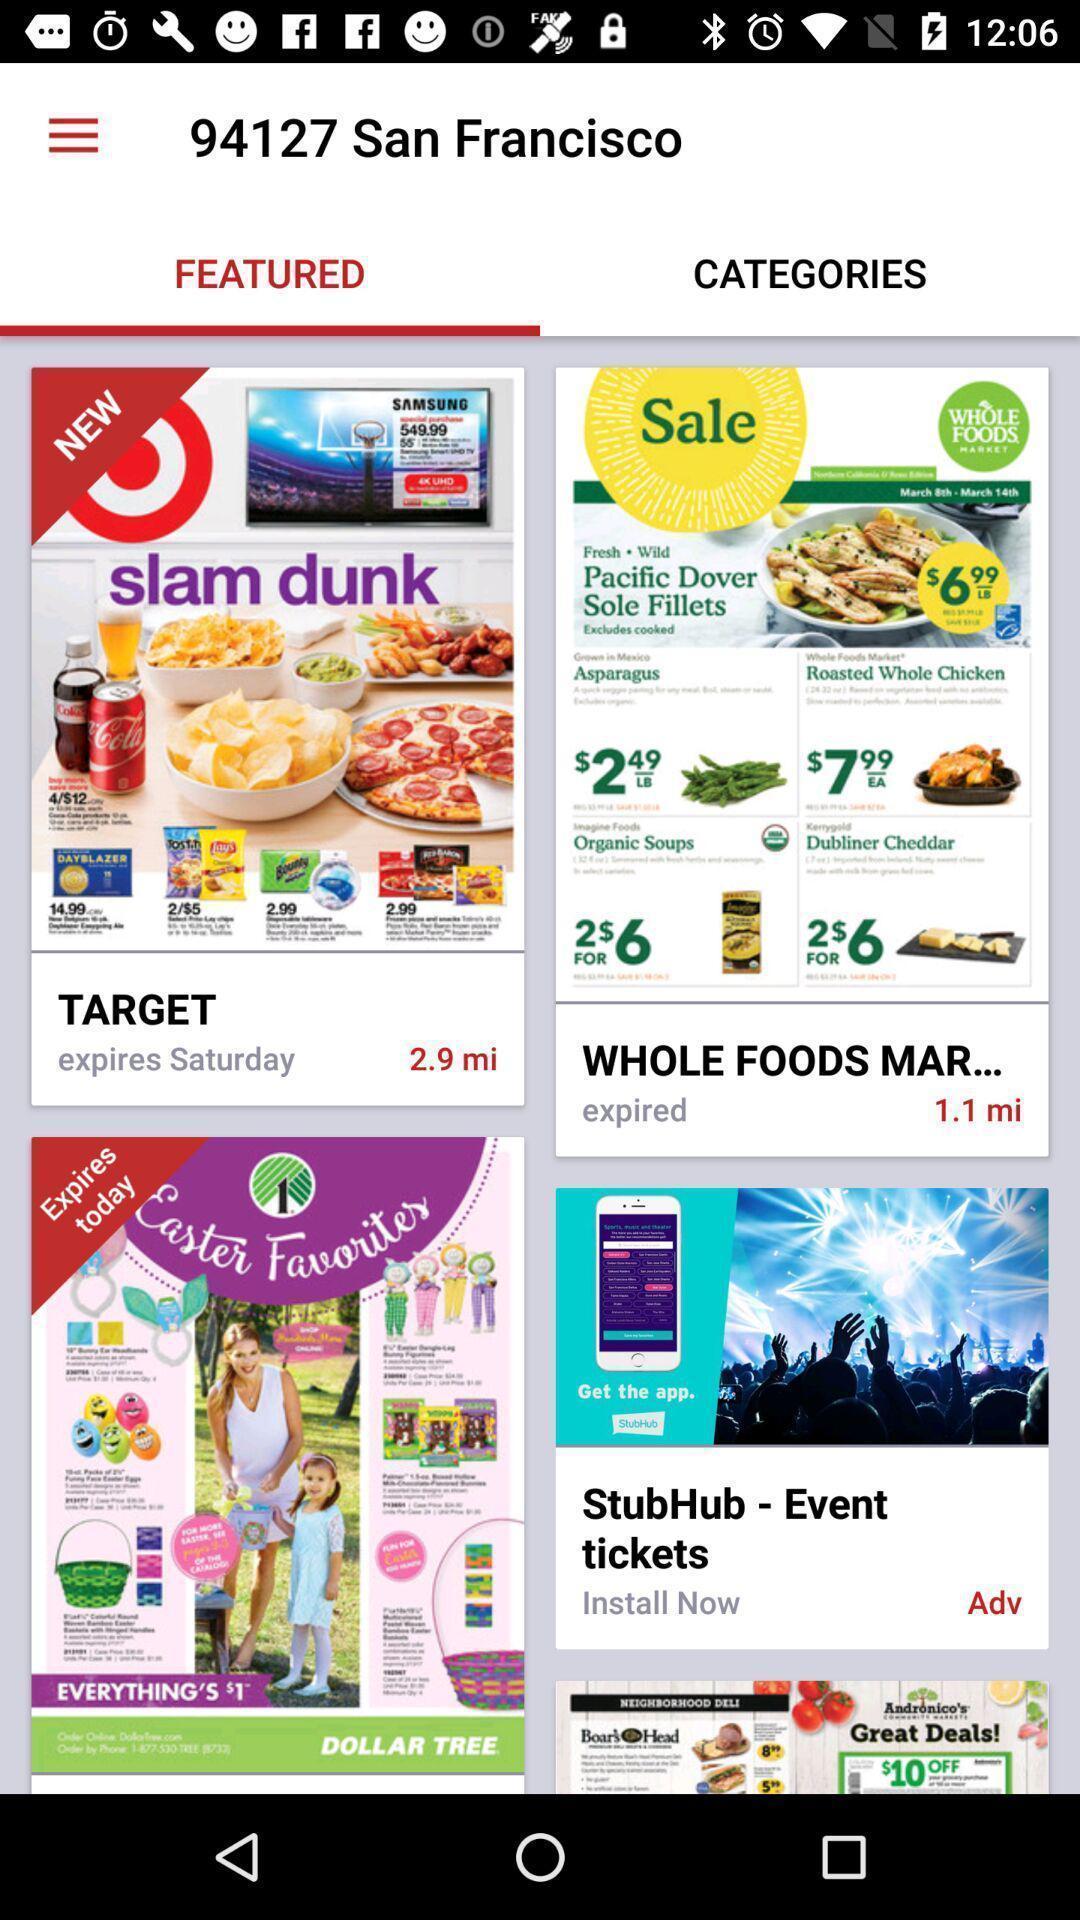Provide a description of this screenshot. Screen displaying multiple featured posters with names. 